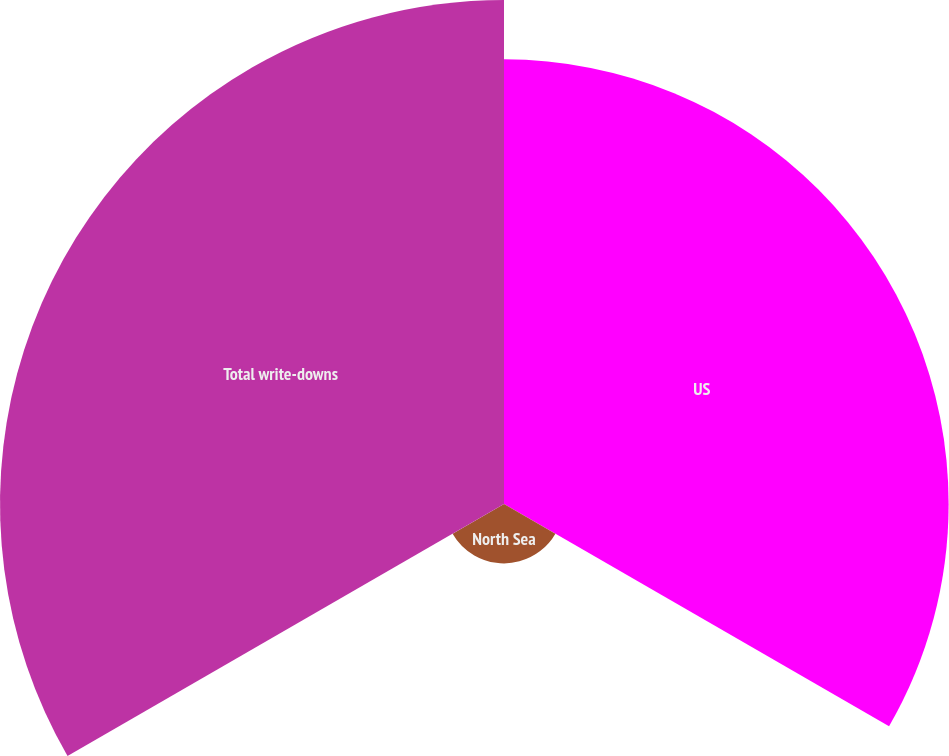<chart> <loc_0><loc_0><loc_500><loc_500><pie_chart><fcel>US<fcel>North Sea<fcel>Total write-downs<nl><fcel>44.11%<fcel>5.89%<fcel>50.0%<nl></chart> 